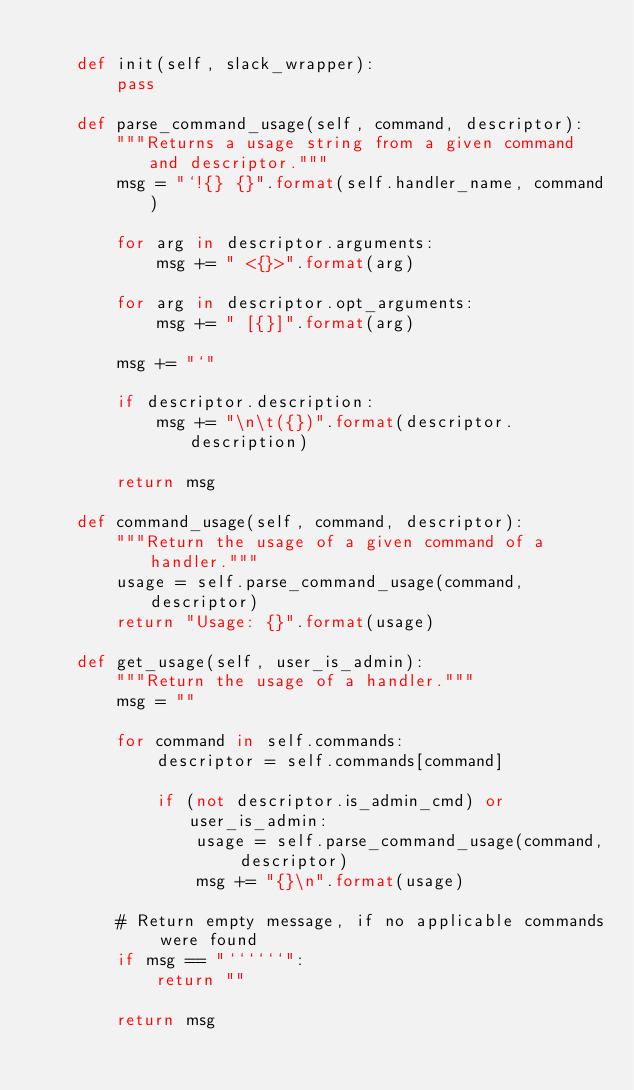<code> <loc_0><loc_0><loc_500><loc_500><_Python_>
    def init(self, slack_wrapper):
        pass

    def parse_command_usage(self, command, descriptor):
        """Returns a usage string from a given command and descriptor."""
        msg = "`!{} {}".format(self.handler_name, command)

        for arg in descriptor.arguments:
            msg += " <{}>".format(arg)

        for arg in descriptor.opt_arguments:
            msg += " [{}]".format(arg)

        msg += "`"

        if descriptor.description:
            msg += "\n\t({})".format(descriptor.description)

        return msg

    def command_usage(self, command, descriptor):
        """Return the usage of a given command of a handler."""
        usage = self.parse_command_usage(command, descriptor)
        return "Usage: {}".format(usage)

    def get_usage(self, user_is_admin):
        """Return the usage of a handler."""
        msg = ""

        for command in self.commands:
            descriptor = self.commands[command]

            if (not descriptor.is_admin_cmd) or user_is_admin:
                usage = self.parse_command_usage(command, descriptor)
                msg += "{}\n".format(usage)

        # Return empty message, if no applicable commands were found
        if msg == "``````":
            return ""

        return msg
</code> 